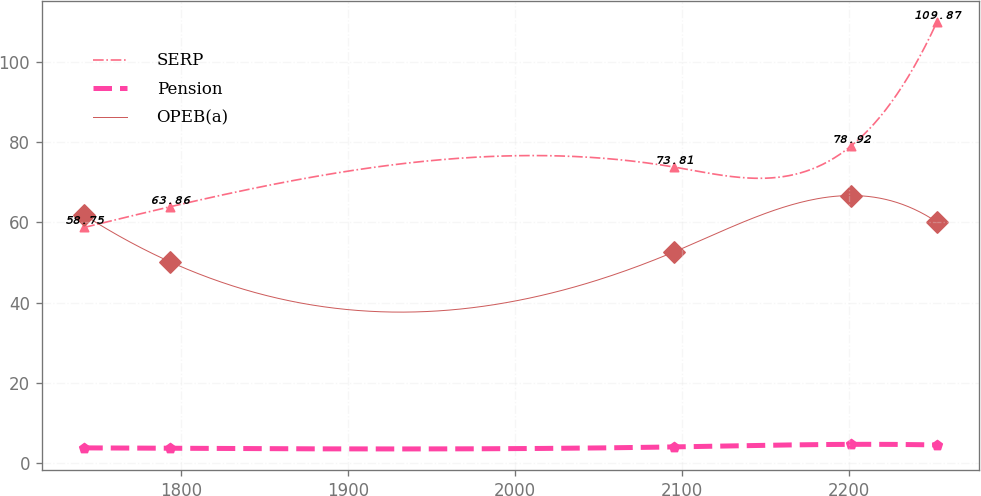Convert chart to OTSL. <chart><loc_0><loc_0><loc_500><loc_500><line_chart><ecel><fcel>SERP<fcel>Pension<fcel>OPEB(a)<nl><fcel>1742.1<fcel>58.75<fcel>3.85<fcel>61.83<nl><fcel>1793.15<fcel>63.86<fcel>3.75<fcel>50.25<nl><fcel>2094.97<fcel>73.81<fcel>4.09<fcel>52.6<nl><fcel>2200.94<fcel>78.92<fcel>4.73<fcel>66.69<nl><fcel>2252.65<fcel>109.87<fcel>4.57<fcel>60.1<nl></chart> 